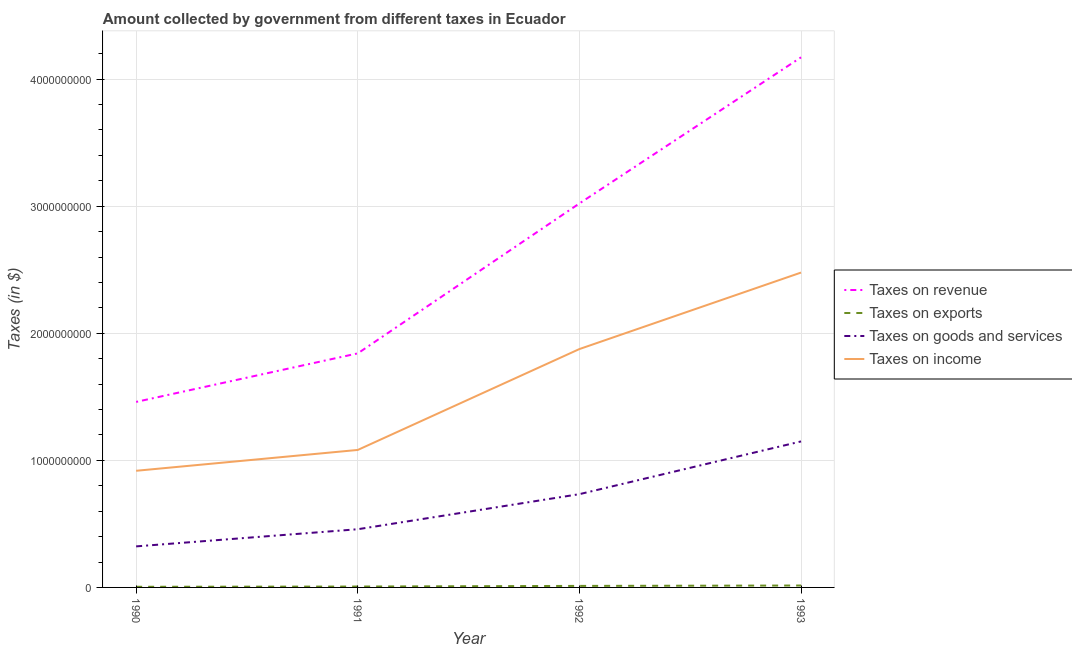How many different coloured lines are there?
Make the answer very short. 4. Does the line corresponding to amount collected as tax on goods intersect with the line corresponding to amount collected as tax on exports?
Offer a very short reply. No. Is the number of lines equal to the number of legend labels?
Give a very brief answer. Yes. What is the amount collected as tax on goods in 1993?
Give a very brief answer. 1.15e+09. Across all years, what is the maximum amount collected as tax on goods?
Give a very brief answer. 1.15e+09. Across all years, what is the minimum amount collected as tax on goods?
Ensure brevity in your answer.  3.23e+08. In which year was the amount collected as tax on exports maximum?
Offer a very short reply. 1993. What is the total amount collected as tax on goods in the graph?
Keep it short and to the point. 2.66e+09. What is the difference between the amount collected as tax on revenue in 1990 and that in 1993?
Your response must be concise. -2.71e+09. What is the difference between the amount collected as tax on exports in 1993 and the amount collected as tax on revenue in 1990?
Your answer should be compact. -1.44e+09. What is the average amount collected as tax on goods per year?
Keep it short and to the point. 6.66e+08. In the year 1990, what is the difference between the amount collected as tax on exports and amount collected as tax on goods?
Keep it short and to the point. -3.18e+08. What is the ratio of the amount collected as tax on goods in 1991 to that in 1993?
Make the answer very short. 0.4. Is the amount collected as tax on goods in 1990 less than that in 1993?
Your answer should be compact. Yes. Is the difference between the amount collected as tax on income in 1991 and 1993 greater than the difference between the amount collected as tax on revenue in 1991 and 1993?
Make the answer very short. Yes. What is the difference between the highest and the second highest amount collected as tax on exports?
Provide a succinct answer. 3.00e+06. What is the difference between the highest and the lowest amount collected as tax on income?
Ensure brevity in your answer.  1.56e+09. Is the sum of the amount collected as tax on exports in 1992 and 1993 greater than the maximum amount collected as tax on income across all years?
Provide a succinct answer. No. Is it the case that in every year, the sum of the amount collected as tax on revenue and amount collected as tax on exports is greater than the amount collected as tax on goods?
Make the answer very short. Yes. Is the amount collected as tax on income strictly greater than the amount collected as tax on revenue over the years?
Make the answer very short. No. How many years are there in the graph?
Offer a very short reply. 4. Are the values on the major ticks of Y-axis written in scientific E-notation?
Offer a very short reply. No. Does the graph contain any zero values?
Your answer should be very brief. No. Does the graph contain grids?
Ensure brevity in your answer.  Yes. Where does the legend appear in the graph?
Your response must be concise. Center right. What is the title of the graph?
Give a very brief answer. Amount collected by government from different taxes in Ecuador. What is the label or title of the X-axis?
Ensure brevity in your answer.  Year. What is the label or title of the Y-axis?
Keep it short and to the point. Taxes (in $). What is the Taxes (in $) of Taxes on revenue in 1990?
Make the answer very short. 1.46e+09. What is the Taxes (in $) in Taxes on exports in 1990?
Keep it short and to the point. 5.00e+06. What is the Taxes (in $) in Taxes on goods and services in 1990?
Keep it short and to the point. 3.23e+08. What is the Taxes (in $) of Taxes on income in 1990?
Offer a very short reply. 9.18e+08. What is the Taxes (in $) of Taxes on revenue in 1991?
Offer a terse response. 1.84e+09. What is the Taxes (in $) of Taxes on goods and services in 1991?
Keep it short and to the point. 4.58e+08. What is the Taxes (in $) of Taxes on income in 1991?
Offer a terse response. 1.08e+09. What is the Taxes (in $) in Taxes on revenue in 1992?
Your response must be concise. 3.02e+09. What is the Taxes (in $) in Taxes on exports in 1992?
Your answer should be very brief. 1.20e+07. What is the Taxes (in $) of Taxes on goods and services in 1992?
Ensure brevity in your answer.  7.34e+08. What is the Taxes (in $) in Taxes on income in 1992?
Give a very brief answer. 1.88e+09. What is the Taxes (in $) of Taxes on revenue in 1993?
Keep it short and to the point. 4.17e+09. What is the Taxes (in $) in Taxes on exports in 1993?
Give a very brief answer. 1.50e+07. What is the Taxes (in $) of Taxes on goods and services in 1993?
Offer a very short reply. 1.15e+09. What is the Taxes (in $) of Taxes on income in 1993?
Offer a very short reply. 2.48e+09. Across all years, what is the maximum Taxes (in $) of Taxes on revenue?
Keep it short and to the point. 4.17e+09. Across all years, what is the maximum Taxes (in $) in Taxes on exports?
Offer a terse response. 1.50e+07. Across all years, what is the maximum Taxes (in $) of Taxes on goods and services?
Provide a succinct answer. 1.15e+09. Across all years, what is the maximum Taxes (in $) of Taxes on income?
Offer a very short reply. 2.48e+09. Across all years, what is the minimum Taxes (in $) in Taxes on revenue?
Offer a terse response. 1.46e+09. Across all years, what is the minimum Taxes (in $) of Taxes on goods and services?
Your answer should be compact. 3.23e+08. Across all years, what is the minimum Taxes (in $) in Taxes on income?
Make the answer very short. 9.18e+08. What is the total Taxes (in $) of Taxes on revenue in the graph?
Your answer should be very brief. 1.05e+1. What is the total Taxes (in $) in Taxes on exports in the graph?
Provide a short and direct response. 3.90e+07. What is the total Taxes (in $) in Taxes on goods and services in the graph?
Give a very brief answer. 2.66e+09. What is the total Taxes (in $) of Taxes on income in the graph?
Give a very brief answer. 6.35e+09. What is the difference between the Taxes (in $) in Taxes on revenue in 1990 and that in 1991?
Provide a succinct answer. -3.82e+08. What is the difference between the Taxes (in $) in Taxes on goods and services in 1990 and that in 1991?
Provide a short and direct response. -1.35e+08. What is the difference between the Taxes (in $) of Taxes on income in 1990 and that in 1991?
Offer a terse response. -1.64e+08. What is the difference between the Taxes (in $) in Taxes on revenue in 1990 and that in 1992?
Offer a terse response. -1.56e+09. What is the difference between the Taxes (in $) in Taxes on exports in 1990 and that in 1992?
Offer a very short reply. -7.00e+06. What is the difference between the Taxes (in $) of Taxes on goods and services in 1990 and that in 1992?
Provide a short and direct response. -4.11e+08. What is the difference between the Taxes (in $) of Taxes on income in 1990 and that in 1992?
Give a very brief answer. -9.58e+08. What is the difference between the Taxes (in $) in Taxes on revenue in 1990 and that in 1993?
Give a very brief answer. -2.71e+09. What is the difference between the Taxes (in $) in Taxes on exports in 1990 and that in 1993?
Your answer should be compact. -1.00e+07. What is the difference between the Taxes (in $) of Taxes on goods and services in 1990 and that in 1993?
Your response must be concise. -8.26e+08. What is the difference between the Taxes (in $) in Taxes on income in 1990 and that in 1993?
Provide a succinct answer. -1.56e+09. What is the difference between the Taxes (in $) of Taxes on revenue in 1991 and that in 1992?
Provide a succinct answer. -1.18e+09. What is the difference between the Taxes (in $) of Taxes on exports in 1991 and that in 1992?
Keep it short and to the point. -5.00e+06. What is the difference between the Taxes (in $) of Taxes on goods and services in 1991 and that in 1992?
Ensure brevity in your answer.  -2.76e+08. What is the difference between the Taxes (in $) of Taxes on income in 1991 and that in 1992?
Your answer should be very brief. -7.94e+08. What is the difference between the Taxes (in $) in Taxes on revenue in 1991 and that in 1993?
Provide a short and direct response. -2.33e+09. What is the difference between the Taxes (in $) in Taxes on exports in 1991 and that in 1993?
Provide a short and direct response. -8.00e+06. What is the difference between the Taxes (in $) in Taxes on goods and services in 1991 and that in 1993?
Your answer should be very brief. -6.91e+08. What is the difference between the Taxes (in $) of Taxes on income in 1991 and that in 1993?
Offer a terse response. -1.40e+09. What is the difference between the Taxes (in $) in Taxes on revenue in 1992 and that in 1993?
Your response must be concise. -1.15e+09. What is the difference between the Taxes (in $) of Taxes on exports in 1992 and that in 1993?
Your answer should be very brief. -3.00e+06. What is the difference between the Taxes (in $) of Taxes on goods and services in 1992 and that in 1993?
Your answer should be compact. -4.15e+08. What is the difference between the Taxes (in $) in Taxes on income in 1992 and that in 1993?
Keep it short and to the point. -6.02e+08. What is the difference between the Taxes (in $) in Taxes on revenue in 1990 and the Taxes (in $) in Taxes on exports in 1991?
Make the answer very short. 1.45e+09. What is the difference between the Taxes (in $) in Taxes on revenue in 1990 and the Taxes (in $) in Taxes on goods and services in 1991?
Ensure brevity in your answer.  1.00e+09. What is the difference between the Taxes (in $) in Taxes on revenue in 1990 and the Taxes (in $) in Taxes on income in 1991?
Your answer should be very brief. 3.78e+08. What is the difference between the Taxes (in $) of Taxes on exports in 1990 and the Taxes (in $) of Taxes on goods and services in 1991?
Offer a terse response. -4.53e+08. What is the difference between the Taxes (in $) in Taxes on exports in 1990 and the Taxes (in $) in Taxes on income in 1991?
Ensure brevity in your answer.  -1.08e+09. What is the difference between the Taxes (in $) of Taxes on goods and services in 1990 and the Taxes (in $) of Taxes on income in 1991?
Keep it short and to the point. -7.59e+08. What is the difference between the Taxes (in $) of Taxes on revenue in 1990 and the Taxes (in $) of Taxes on exports in 1992?
Ensure brevity in your answer.  1.45e+09. What is the difference between the Taxes (in $) of Taxes on revenue in 1990 and the Taxes (in $) of Taxes on goods and services in 1992?
Offer a very short reply. 7.26e+08. What is the difference between the Taxes (in $) in Taxes on revenue in 1990 and the Taxes (in $) in Taxes on income in 1992?
Offer a terse response. -4.16e+08. What is the difference between the Taxes (in $) in Taxes on exports in 1990 and the Taxes (in $) in Taxes on goods and services in 1992?
Offer a very short reply. -7.29e+08. What is the difference between the Taxes (in $) of Taxes on exports in 1990 and the Taxes (in $) of Taxes on income in 1992?
Provide a succinct answer. -1.87e+09. What is the difference between the Taxes (in $) of Taxes on goods and services in 1990 and the Taxes (in $) of Taxes on income in 1992?
Provide a short and direct response. -1.55e+09. What is the difference between the Taxes (in $) of Taxes on revenue in 1990 and the Taxes (in $) of Taxes on exports in 1993?
Give a very brief answer. 1.44e+09. What is the difference between the Taxes (in $) in Taxes on revenue in 1990 and the Taxes (in $) in Taxes on goods and services in 1993?
Your response must be concise. 3.11e+08. What is the difference between the Taxes (in $) in Taxes on revenue in 1990 and the Taxes (in $) in Taxes on income in 1993?
Make the answer very short. -1.02e+09. What is the difference between the Taxes (in $) in Taxes on exports in 1990 and the Taxes (in $) in Taxes on goods and services in 1993?
Give a very brief answer. -1.14e+09. What is the difference between the Taxes (in $) of Taxes on exports in 1990 and the Taxes (in $) of Taxes on income in 1993?
Offer a very short reply. -2.47e+09. What is the difference between the Taxes (in $) in Taxes on goods and services in 1990 and the Taxes (in $) in Taxes on income in 1993?
Offer a very short reply. -2.16e+09. What is the difference between the Taxes (in $) in Taxes on revenue in 1991 and the Taxes (in $) in Taxes on exports in 1992?
Your answer should be very brief. 1.83e+09. What is the difference between the Taxes (in $) of Taxes on revenue in 1991 and the Taxes (in $) of Taxes on goods and services in 1992?
Give a very brief answer. 1.11e+09. What is the difference between the Taxes (in $) of Taxes on revenue in 1991 and the Taxes (in $) of Taxes on income in 1992?
Provide a succinct answer. -3.40e+07. What is the difference between the Taxes (in $) of Taxes on exports in 1991 and the Taxes (in $) of Taxes on goods and services in 1992?
Ensure brevity in your answer.  -7.27e+08. What is the difference between the Taxes (in $) in Taxes on exports in 1991 and the Taxes (in $) in Taxes on income in 1992?
Keep it short and to the point. -1.87e+09. What is the difference between the Taxes (in $) in Taxes on goods and services in 1991 and the Taxes (in $) in Taxes on income in 1992?
Your response must be concise. -1.42e+09. What is the difference between the Taxes (in $) in Taxes on revenue in 1991 and the Taxes (in $) in Taxes on exports in 1993?
Ensure brevity in your answer.  1.83e+09. What is the difference between the Taxes (in $) of Taxes on revenue in 1991 and the Taxes (in $) of Taxes on goods and services in 1993?
Provide a succinct answer. 6.93e+08. What is the difference between the Taxes (in $) of Taxes on revenue in 1991 and the Taxes (in $) of Taxes on income in 1993?
Give a very brief answer. -6.36e+08. What is the difference between the Taxes (in $) of Taxes on exports in 1991 and the Taxes (in $) of Taxes on goods and services in 1993?
Provide a succinct answer. -1.14e+09. What is the difference between the Taxes (in $) of Taxes on exports in 1991 and the Taxes (in $) of Taxes on income in 1993?
Ensure brevity in your answer.  -2.47e+09. What is the difference between the Taxes (in $) of Taxes on goods and services in 1991 and the Taxes (in $) of Taxes on income in 1993?
Offer a terse response. -2.02e+09. What is the difference between the Taxes (in $) in Taxes on revenue in 1992 and the Taxes (in $) in Taxes on exports in 1993?
Make the answer very short. 3.01e+09. What is the difference between the Taxes (in $) of Taxes on revenue in 1992 and the Taxes (in $) of Taxes on goods and services in 1993?
Offer a terse response. 1.87e+09. What is the difference between the Taxes (in $) in Taxes on revenue in 1992 and the Taxes (in $) in Taxes on income in 1993?
Your answer should be compact. 5.44e+08. What is the difference between the Taxes (in $) of Taxes on exports in 1992 and the Taxes (in $) of Taxes on goods and services in 1993?
Make the answer very short. -1.14e+09. What is the difference between the Taxes (in $) of Taxes on exports in 1992 and the Taxes (in $) of Taxes on income in 1993?
Keep it short and to the point. -2.47e+09. What is the difference between the Taxes (in $) of Taxes on goods and services in 1992 and the Taxes (in $) of Taxes on income in 1993?
Give a very brief answer. -1.74e+09. What is the average Taxes (in $) of Taxes on revenue per year?
Your answer should be compact. 2.62e+09. What is the average Taxes (in $) in Taxes on exports per year?
Give a very brief answer. 9.75e+06. What is the average Taxes (in $) in Taxes on goods and services per year?
Your answer should be compact. 6.66e+08. What is the average Taxes (in $) of Taxes on income per year?
Give a very brief answer. 1.59e+09. In the year 1990, what is the difference between the Taxes (in $) in Taxes on revenue and Taxes (in $) in Taxes on exports?
Ensure brevity in your answer.  1.46e+09. In the year 1990, what is the difference between the Taxes (in $) in Taxes on revenue and Taxes (in $) in Taxes on goods and services?
Make the answer very short. 1.14e+09. In the year 1990, what is the difference between the Taxes (in $) of Taxes on revenue and Taxes (in $) of Taxes on income?
Your answer should be very brief. 5.42e+08. In the year 1990, what is the difference between the Taxes (in $) of Taxes on exports and Taxes (in $) of Taxes on goods and services?
Keep it short and to the point. -3.18e+08. In the year 1990, what is the difference between the Taxes (in $) in Taxes on exports and Taxes (in $) in Taxes on income?
Your answer should be compact. -9.13e+08. In the year 1990, what is the difference between the Taxes (in $) of Taxes on goods and services and Taxes (in $) of Taxes on income?
Offer a very short reply. -5.95e+08. In the year 1991, what is the difference between the Taxes (in $) of Taxes on revenue and Taxes (in $) of Taxes on exports?
Your answer should be very brief. 1.84e+09. In the year 1991, what is the difference between the Taxes (in $) of Taxes on revenue and Taxes (in $) of Taxes on goods and services?
Offer a terse response. 1.38e+09. In the year 1991, what is the difference between the Taxes (in $) in Taxes on revenue and Taxes (in $) in Taxes on income?
Your answer should be very brief. 7.60e+08. In the year 1991, what is the difference between the Taxes (in $) of Taxes on exports and Taxes (in $) of Taxes on goods and services?
Provide a succinct answer. -4.51e+08. In the year 1991, what is the difference between the Taxes (in $) of Taxes on exports and Taxes (in $) of Taxes on income?
Keep it short and to the point. -1.08e+09. In the year 1991, what is the difference between the Taxes (in $) of Taxes on goods and services and Taxes (in $) of Taxes on income?
Offer a very short reply. -6.24e+08. In the year 1992, what is the difference between the Taxes (in $) of Taxes on revenue and Taxes (in $) of Taxes on exports?
Provide a short and direct response. 3.01e+09. In the year 1992, what is the difference between the Taxes (in $) in Taxes on revenue and Taxes (in $) in Taxes on goods and services?
Your response must be concise. 2.29e+09. In the year 1992, what is the difference between the Taxes (in $) in Taxes on revenue and Taxes (in $) in Taxes on income?
Your response must be concise. 1.15e+09. In the year 1992, what is the difference between the Taxes (in $) in Taxes on exports and Taxes (in $) in Taxes on goods and services?
Keep it short and to the point. -7.22e+08. In the year 1992, what is the difference between the Taxes (in $) in Taxes on exports and Taxes (in $) in Taxes on income?
Your answer should be very brief. -1.86e+09. In the year 1992, what is the difference between the Taxes (in $) in Taxes on goods and services and Taxes (in $) in Taxes on income?
Give a very brief answer. -1.14e+09. In the year 1993, what is the difference between the Taxes (in $) of Taxes on revenue and Taxes (in $) of Taxes on exports?
Give a very brief answer. 4.16e+09. In the year 1993, what is the difference between the Taxes (in $) of Taxes on revenue and Taxes (in $) of Taxes on goods and services?
Provide a succinct answer. 3.02e+09. In the year 1993, what is the difference between the Taxes (in $) in Taxes on revenue and Taxes (in $) in Taxes on income?
Your answer should be very brief. 1.69e+09. In the year 1993, what is the difference between the Taxes (in $) in Taxes on exports and Taxes (in $) in Taxes on goods and services?
Ensure brevity in your answer.  -1.13e+09. In the year 1993, what is the difference between the Taxes (in $) in Taxes on exports and Taxes (in $) in Taxes on income?
Provide a short and direct response. -2.46e+09. In the year 1993, what is the difference between the Taxes (in $) in Taxes on goods and services and Taxes (in $) in Taxes on income?
Keep it short and to the point. -1.33e+09. What is the ratio of the Taxes (in $) of Taxes on revenue in 1990 to that in 1991?
Offer a very short reply. 0.79. What is the ratio of the Taxes (in $) in Taxes on goods and services in 1990 to that in 1991?
Your answer should be compact. 0.71. What is the ratio of the Taxes (in $) of Taxes on income in 1990 to that in 1991?
Ensure brevity in your answer.  0.85. What is the ratio of the Taxes (in $) of Taxes on revenue in 1990 to that in 1992?
Make the answer very short. 0.48. What is the ratio of the Taxes (in $) of Taxes on exports in 1990 to that in 1992?
Make the answer very short. 0.42. What is the ratio of the Taxes (in $) in Taxes on goods and services in 1990 to that in 1992?
Keep it short and to the point. 0.44. What is the ratio of the Taxes (in $) of Taxes on income in 1990 to that in 1992?
Your answer should be compact. 0.49. What is the ratio of the Taxes (in $) in Taxes on revenue in 1990 to that in 1993?
Offer a very short reply. 0.35. What is the ratio of the Taxes (in $) in Taxes on exports in 1990 to that in 1993?
Make the answer very short. 0.33. What is the ratio of the Taxes (in $) in Taxes on goods and services in 1990 to that in 1993?
Keep it short and to the point. 0.28. What is the ratio of the Taxes (in $) in Taxes on income in 1990 to that in 1993?
Your response must be concise. 0.37. What is the ratio of the Taxes (in $) of Taxes on revenue in 1991 to that in 1992?
Your answer should be compact. 0.61. What is the ratio of the Taxes (in $) of Taxes on exports in 1991 to that in 1992?
Ensure brevity in your answer.  0.58. What is the ratio of the Taxes (in $) of Taxes on goods and services in 1991 to that in 1992?
Give a very brief answer. 0.62. What is the ratio of the Taxes (in $) of Taxes on income in 1991 to that in 1992?
Provide a short and direct response. 0.58. What is the ratio of the Taxes (in $) in Taxes on revenue in 1991 to that in 1993?
Offer a terse response. 0.44. What is the ratio of the Taxes (in $) of Taxes on exports in 1991 to that in 1993?
Offer a very short reply. 0.47. What is the ratio of the Taxes (in $) in Taxes on goods and services in 1991 to that in 1993?
Ensure brevity in your answer.  0.4. What is the ratio of the Taxes (in $) of Taxes on income in 1991 to that in 1993?
Offer a terse response. 0.44. What is the ratio of the Taxes (in $) of Taxes on revenue in 1992 to that in 1993?
Your answer should be compact. 0.72. What is the ratio of the Taxes (in $) in Taxes on exports in 1992 to that in 1993?
Your response must be concise. 0.8. What is the ratio of the Taxes (in $) in Taxes on goods and services in 1992 to that in 1993?
Your response must be concise. 0.64. What is the ratio of the Taxes (in $) in Taxes on income in 1992 to that in 1993?
Ensure brevity in your answer.  0.76. What is the difference between the highest and the second highest Taxes (in $) in Taxes on revenue?
Give a very brief answer. 1.15e+09. What is the difference between the highest and the second highest Taxes (in $) of Taxes on exports?
Your answer should be compact. 3.00e+06. What is the difference between the highest and the second highest Taxes (in $) of Taxes on goods and services?
Provide a short and direct response. 4.15e+08. What is the difference between the highest and the second highest Taxes (in $) of Taxes on income?
Give a very brief answer. 6.02e+08. What is the difference between the highest and the lowest Taxes (in $) in Taxes on revenue?
Your answer should be very brief. 2.71e+09. What is the difference between the highest and the lowest Taxes (in $) in Taxes on goods and services?
Keep it short and to the point. 8.26e+08. What is the difference between the highest and the lowest Taxes (in $) of Taxes on income?
Keep it short and to the point. 1.56e+09. 